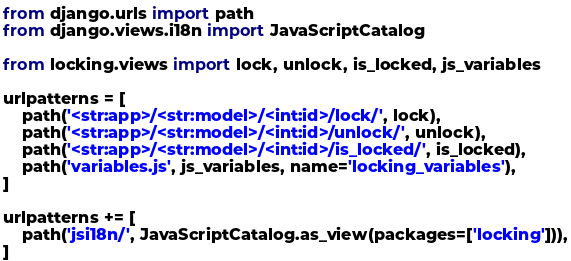Convert code to text. <code><loc_0><loc_0><loc_500><loc_500><_Python_>from django.urls import path
from django.views.i18n import JavaScriptCatalog

from locking.views import lock, unlock, is_locked, js_variables

urlpatterns = [
    path('<str:app>/<str:model>/<int:id>/lock/', lock),
    path('<str:app>/<str:model>/<int:id>/unlock/', unlock),
    path('<str:app>/<str:model>/<int:id>/is_locked/', is_locked),
    path('variables.js', js_variables, name='locking_variables'),
]

urlpatterns += [
    path('jsi18n/', JavaScriptCatalog.as_view(packages=['locking'])),
]
</code> 